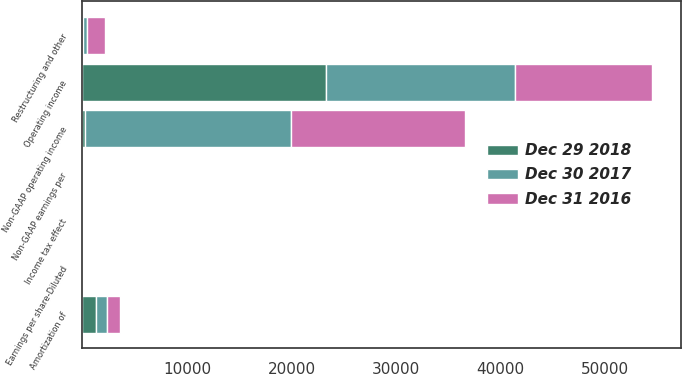Convert chart. <chart><loc_0><loc_0><loc_500><loc_500><stacked_bar_chart><ecel><fcel>Operating income<fcel>Amortization of<fcel>Restructuring and other<fcel>Non-GAAP operating income<fcel>Earnings per share-Diluted<fcel>Income tax effect<fcel>Non-GAAP earnings per<nl><fcel>Dec 29 2018<fcel>23316<fcel>1305<fcel>72<fcel>228<fcel>4.48<fcel>0.02<fcel>4.58<nl><fcel>Dec 30 2017<fcel>18050<fcel>1089<fcel>384<fcel>19691<fcel>1.99<fcel>0.09<fcel>3.46<nl><fcel>Dec 31 2016<fcel>13133<fcel>1231<fcel>1744<fcel>16659<fcel>2.12<fcel>0.15<fcel>2.72<nl></chart> 